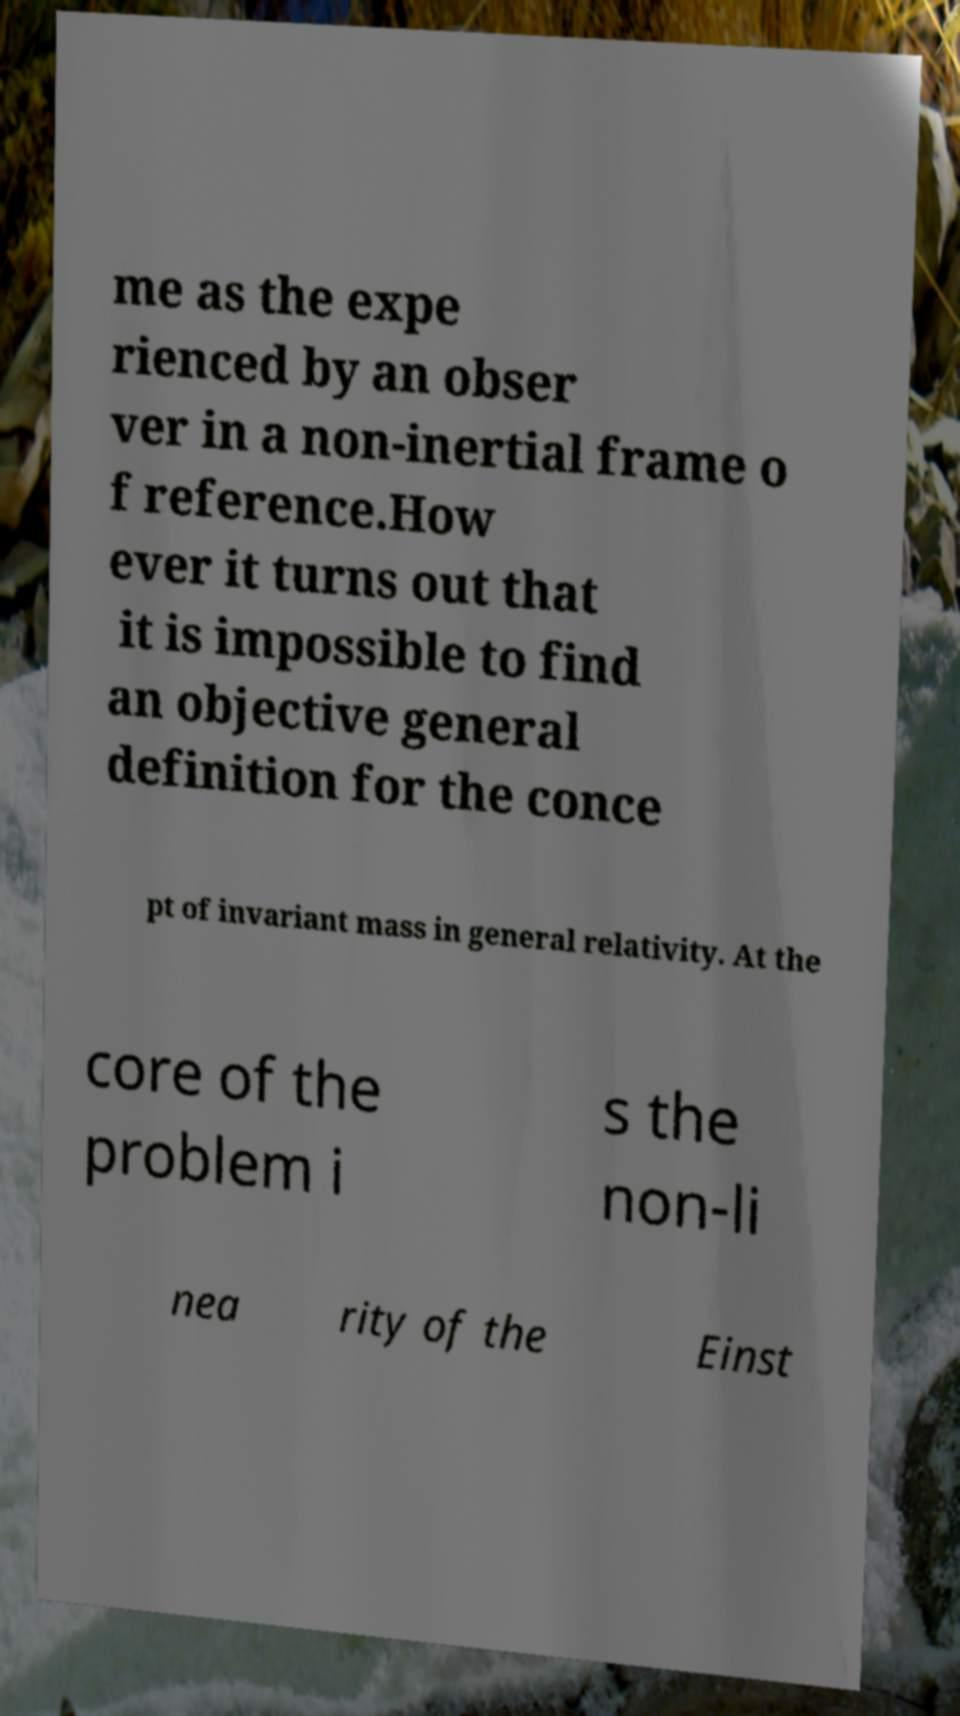I need the written content from this picture converted into text. Can you do that? me as the expe rienced by an obser ver in a non-inertial frame o f reference.How ever it turns out that it is impossible to find an objective general definition for the conce pt of invariant mass in general relativity. At the core of the problem i s the non-li nea rity of the Einst 